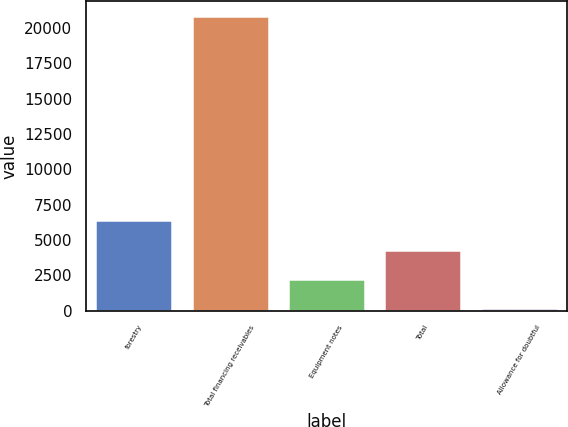<chart> <loc_0><loc_0><loc_500><loc_500><bar_chart><fcel>forestry<fcel>Total financing receivables<fcel>Equipment notes<fcel>Total<fcel>Allowance for doubtful<nl><fcel>6383<fcel>20859<fcel>2247<fcel>4315<fcel>179<nl></chart> 